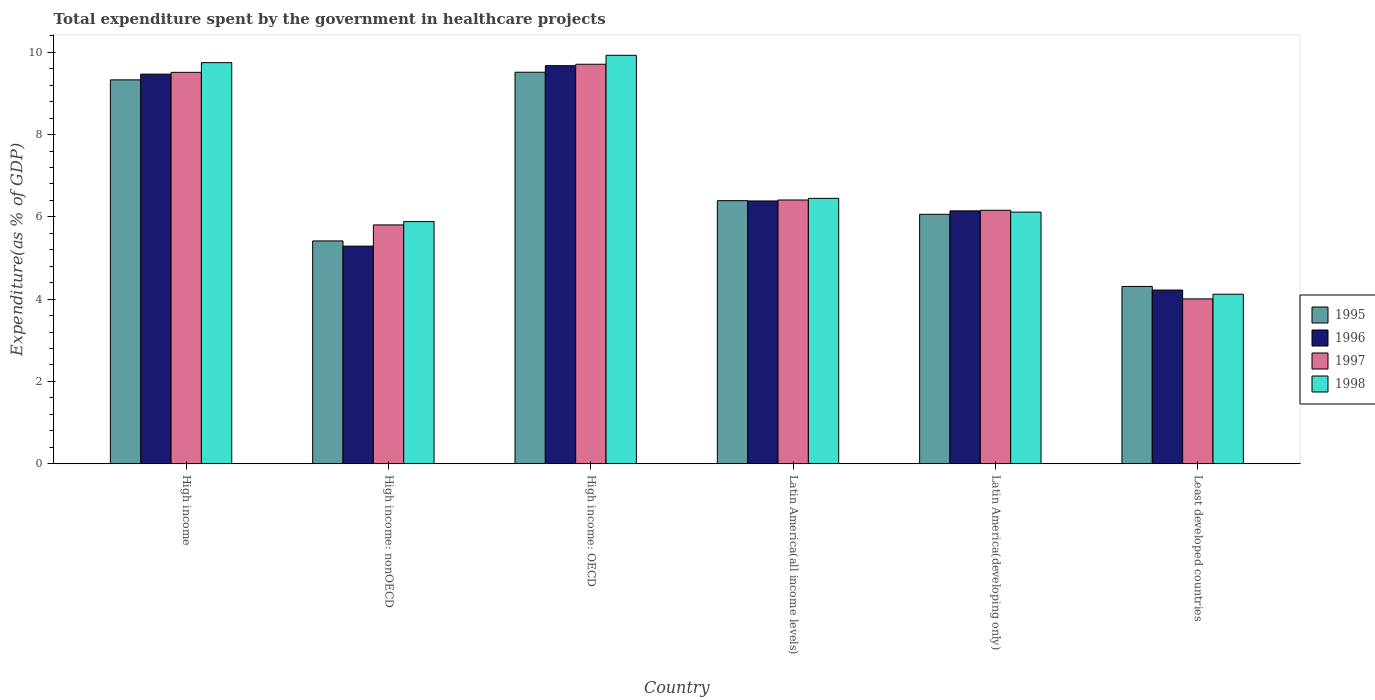Are the number of bars per tick equal to the number of legend labels?
Your answer should be very brief. Yes. Are the number of bars on each tick of the X-axis equal?
Offer a very short reply. Yes. What is the label of the 2nd group of bars from the left?
Make the answer very short. High income: nonOECD. What is the total expenditure spent by the government in healthcare projects in 1997 in High income: OECD?
Ensure brevity in your answer.  9.71. Across all countries, what is the maximum total expenditure spent by the government in healthcare projects in 1998?
Make the answer very short. 9.93. Across all countries, what is the minimum total expenditure spent by the government in healthcare projects in 1998?
Keep it short and to the point. 4.12. In which country was the total expenditure spent by the government in healthcare projects in 1996 maximum?
Keep it short and to the point. High income: OECD. In which country was the total expenditure spent by the government in healthcare projects in 1998 minimum?
Offer a very short reply. Least developed countries. What is the total total expenditure spent by the government in healthcare projects in 1996 in the graph?
Offer a very short reply. 41.18. What is the difference between the total expenditure spent by the government in healthcare projects in 1997 in Latin America(all income levels) and that in Latin America(developing only)?
Ensure brevity in your answer.  0.25. What is the difference between the total expenditure spent by the government in healthcare projects in 1996 in High income: nonOECD and the total expenditure spent by the government in healthcare projects in 1998 in Least developed countries?
Your answer should be very brief. 1.17. What is the average total expenditure spent by the government in healthcare projects in 1998 per country?
Offer a terse response. 7.04. What is the difference between the total expenditure spent by the government in healthcare projects of/in 1995 and total expenditure spent by the government in healthcare projects of/in 1996 in High income?
Offer a terse response. -0.14. In how many countries, is the total expenditure spent by the government in healthcare projects in 1998 greater than 8 %?
Ensure brevity in your answer.  2. What is the ratio of the total expenditure spent by the government in healthcare projects in 1998 in Latin America(developing only) to that in Least developed countries?
Your answer should be very brief. 1.48. Is the total expenditure spent by the government in healthcare projects in 1995 in High income: OECD less than that in Latin America(developing only)?
Give a very brief answer. No. What is the difference between the highest and the second highest total expenditure spent by the government in healthcare projects in 1996?
Ensure brevity in your answer.  0.2. What is the difference between the highest and the lowest total expenditure spent by the government in healthcare projects in 1997?
Your answer should be compact. 5.7. In how many countries, is the total expenditure spent by the government in healthcare projects in 1995 greater than the average total expenditure spent by the government in healthcare projects in 1995 taken over all countries?
Your answer should be compact. 2. Is it the case that in every country, the sum of the total expenditure spent by the government in healthcare projects in 1996 and total expenditure spent by the government in healthcare projects in 1997 is greater than the sum of total expenditure spent by the government in healthcare projects in 1998 and total expenditure spent by the government in healthcare projects in 1995?
Offer a terse response. No. What does the 3rd bar from the left in Latin America(all income levels) represents?
Your answer should be compact. 1997. How many countries are there in the graph?
Provide a succinct answer. 6. Where does the legend appear in the graph?
Offer a very short reply. Center right. How many legend labels are there?
Your answer should be very brief. 4. What is the title of the graph?
Give a very brief answer. Total expenditure spent by the government in healthcare projects. What is the label or title of the X-axis?
Keep it short and to the point. Country. What is the label or title of the Y-axis?
Provide a succinct answer. Expenditure(as % of GDP). What is the Expenditure(as % of GDP) of 1995 in High income?
Offer a terse response. 9.33. What is the Expenditure(as % of GDP) of 1996 in High income?
Offer a terse response. 9.47. What is the Expenditure(as % of GDP) in 1997 in High income?
Offer a very short reply. 9.51. What is the Expenditure(as % of GDP) of 1998 in High income?
Keep it short and to the point. 9.75. What is the Expenditure(as % of GDP) in 1995 in High income: nonOECD?
Your response must be concise. 5.41. What is the Expenditure(as % of GDP) of 1996 in High income: nonOECD?
Provide a succinct answer. 5.29. What is the Expenditure(as % of GDP) of 1997 in High income: nonOECD?
Your answer should be very brief. 5.8. What is the Expenditure(as % of GDP) of 1998 in High income: nonOECD?
Your answer should be very brief. 5.88. What is the Expenditure(as % of GDP) of 1995 in High income: OECD?
Ensure brevity in your answer.  9.51. What is the Expenditure(as % of GDP) of 1996 in High income: OECD?
Ensure brevity in your answer.  9.67. What is the Expenditure(as % of GDP) of 1997 in High income: OECD?
Your answer should be very brief. 9.71. What is the Expenditure(as % of GDP) of 1998 in High income: OECD?
Keep it short and to the point. 9.93. What is the Expenditure(as % of GDP) of 1995 in Latin America(all income levels)?
Give a very brief answer. 6.39. What is the Expenditure(as % of GDP) of 1996 in Latin America(all income levels)?
Provide a short and direct response. 6.39. What is the Expenditure(as % of GDP) in 1997 in Latin America(all income levels)?
Provide a succinct answer. 6.41. What is the Expenditure(as % of GDP) of 1998 in Latin America(all income levels)?
Your answer should be very brief. 6.45. What is the Expenditure(as % of GDP) in 1995 in Latin America(developing only)?
Your answer should be compact. 6.06. What is the Expenditure(as % of GDP) of 1996 in Latin America(developing only)?
Ensure brevity in your answer.  6.15. What is the Expenditure(as % of GDP) of 1997 in Latin America(developing only)?
Offer a very short reply. 6.16. What is the Expenditure(as % of GDP) of 1998 in Latin America(developing only)?
Ensure brevity in your answer.  6.12. What is the Expenditure(as % of GDP) in 1995 in Least developed countries?
Offer a terse response. 4.31. What is the Expenditure(as % of GDP) in 1996 in Least developed countries?
Ensure brevity in your answer.  4.22. What is the Expenditure(as % of GDP) in 1997 in Least developed countries?
Your answer should be very brief. 4.01. What is the Expenditure(as % of GDP) in 1998 in Least developed countries?
Keep it short and to the point. 4.12. Across all countries, what is the maximum Expenditure(as % of GDP) in 1995?
Ensure brevity in your answer.  9.51. Across all countries, what is the maximum Expenditure(as % of GDP) of 1996?
Give a very brief answer. 9.67. Across all countries, what is the maximum Expenditure(as % of GDP) of 1997?
Ensure brevity in your answer.  9.71. Across all countries, what is the maximum Expenditure(as % of GDP) of 1998?
Keep it short and to the point. 9.93. Across all countries, what is the minimum Expenditure(as % of GDP) of 1995?
Keep it short and to the point. 4.31. Across all countries, what is the minimum Expenditure(as % of GDP) in 1996?
Give a very brief answer. 4.22. Across all countries, what is the minimum Expenditure(as % of GDP) of 1997?
Provide a short and direct response. 4.01. Across all countries, what is the minimum Expenditure(as % of GDP) in 1998?
Ensure brevity in your answer.  4.12. What is the total Expenditure(as % of GDP) in 1995 in the graph?
Offer a terse response. 41.02. What is the total Expenditure(as % of GDP) of 1996 in the graph?
Offer a very short reply. 41.18. What is the total Expenditure(as % of GDP) of 1997 in the graph?
Your response must be concise. 41.6. What is the total Expenditure(as % of GDP) of 1998 in the graph?
Your answer should be very brief. 42.24. What is the difference between the Expenditure(as % of GDP) of 1995 in High income and that in High income: nonOECD?
Ensure brevity in your answer.  3.91. What is the difference between the Expenditure(as % of GDP) of 1996 in High income and that in High income: nonOECD?
Your response must be concise. 4.18. What is the difference between the Expenditure(as % of GDP) of 1997 in High income and that in High income: nonOECD?
Provide a succinct answer. 3.71. What is the difference between the Expenditure(as % of GDP) of 1998 in High income and that in High income: nonOECD?
Your response must be concise. 3.86. What is the difference between the Expenditure(as % of GDP) of 1995 in High income and that in High income: OECD?
Provide a succinct answer. -0.19. What is the difference between the Expenditure(as % of GDP) in 1996 in High income and that in High income: OECD?
Your answer should be very brief. -0.2. What is the difference between the Expenditure(as % of GDP) in 1997 in High income and that in High income: OECD?
Provide a short and direct response. -0.2. What is the difference between the Expenditure(as % of GDP) in 1998 in High income and that in High income: OECD?
Make the answer very short. -0.18. What is the difference between the Expenditure(as % of GDP) of 1995 in High income and that in Latin America(all income levels)?
Give a very brief answer. 2.94. What is the difference between the Expenditure(as % of GDP) in 1996 in High income and that in Latin America(all income levels)?
Provide a succinct answer. 3.08. What is the difference between the Expenditure(as % of GDP) of 1997 in High income and that in Latin America(all income levels)?
Your answer should be compact. 3.1. What is the difference between the Expenditure(as % of GDP) of 1998 in High income and that in Latin America(all income levels)?
Your answer should be compact. 3.3. What is the difference between the Expenditure(as % of GDP) in 1995 in High income and that in Latin America(developing only)?
Keep it short and to the point. 3.27. What is the difference between the Expenditure(as % of GDP) in 1996 in High income and that in Latin America(developing only)?
Your response must be concise. 3.32. What is the difference between the Expenditure(as % of GDP) of 1997 in High income and that in Latin America(developing only)?
Give a very brief answer. 3.35. What is the difference between the Expenditure(as % of GDP) in 1998 in High income and that in Latin America(developing only)?
Keep it short and to the point. 3.63. What is the difference between the Expenditure(as % of GDP) of 1995 in High income and that in Least developed countries?
Your answer should be very brief. 5.02. What is the difference between the Expenditure(as % of GDP) in 1996 in High income and that in Least developed countries?
Your response must be concise. 5.25. What is the difference between the Expenditure(as % of GDP) in 1997 in High income and that in Least developed countries?
Give a very brief answer. 5.51. What is the difference between the Expenditure(as % of GDP) of 1998 in High income and that in Least developed countries?
Give a very brief answer. 5.63. What is the difference between the Expenditure(as % of GDP) in 1995 in High income: nonOECD and that in High income: OECD?
Your answer should be very brief. -4.1. What is the difference between the Expenditure(as % of GDP) in 1996 in High income: nonOECD and that in High income: OECD?
Ensure brevity in your answer.  -4.38. What is the difference between the Expenditure(as % of GDP) in 1997 in High income: nonOECD and that in High income: OECD?
Provide a short and direct response. -3.9. What is the difference between the Expenditure(as % of GDP) in 1998 in High income: nonOECD and that in High income: OECD?
Provide a short and direct response. -4.04. What is the difference between the Expenditure(as % of GDP) in 1995 in High income: nonOECD and that in Latin America(all income levels)?
Offer a terse response. -0.98. What is the difference between the Expenditure(as % of GDP) in 1996 in High income: nonOECD and that in Latin America(all income levels)?
Your answer should be compact. -1.1. What is the difference between the Expenditure(as % of GDP) in 1997 in High income: nonOECD and that in Latin America(all income levels)?
Ensure brevity in your answer.  -0.61. What is the difference between the Expenditure(as % of GDP) in 1998 in High income: nonOECD and that in Latin America(all income levels)?
Your response must be concise. -0.56. What is the difference between the Expenditure(as % of GDP) of 1995 in High income: nonOECD and that in Latin America(developing only)?
Provide a short and direct response. -0.65. What is the difference between the Expenditure(as % of GDP) of 1996 in High income: nonOECD and that in Latin America(developing only)?
Keep it short and to the point. -0.86. What is the difference between the Expenditure(as % of GDP) of 1997 in High income: nonOECD and that in Latin America(developing only)?
Ensure brevity in your answer.  -0.36. What is the difference between the Expenditure(as % of GDP) in 1998 in High income: nonOECD and that in Latin America(developing only)?
Your answer should be very brief. -0.23. What is the difference between the Expenditure(as % of GDP) of 1995 in High income: nonOECD and that in Least developed countries?
Ensure brevity in your answer.  1.11. What is the difference between the Expenditure(as % of GDP) in 1996 in High income: nonOECD and that in Least developed countries?
Your response must be concise. 1.07. What is the difference between the Expenditure(as % of GDP) of 1997 in High income: nonOECD and that in Least developed countries?
Offer a terse response. 1.8. What is the difference between the Expenditure(as % of GDP) in 1998 in High income: nonOECD and that in Least developed countries?
Ensure brevity in your answer.  1.76. What is the difference between the Expenditure(as % of GDP) in 1995 in High income: OECD and that in Latin America(all income levels)?
Provide a succinct answer. 3.12. What is the difference between the Expenditure(as % of GDP) in 1996 in High income: OECD and that in Latin America(all income levels)?
Make the answer very short. 3.29. What is the difference between the Expenditure(as % of GDP) of 1997 in High income: OECD and that in Latin America(all income levels)?
Offer a very short reply. 3.3. What is the difference between the Expenditure(as % of GDP) of 1998 in High income: OECD and that in Latin America(all income levels)?
Your response must be concise. 3.48. What is the difference between the Expenditure(as % of GDP) in 1995 in High income: OECD and that in Latin America(developing only)?
Provide a succinct answer. 3.45. What is the difference between the Expenditure(as % of GDP) in 1996 in High income: OECD and that in Latin America(developing only)?
Offer a terse response. 3.53. What is the difference between the Expenditure(as % of GDP) in 1997 in High income: OECD and that in Latin America(developing only)?
Your answer should be very brief. 3.55. What is the difference between the Expenditure(as % of GDP) in 1998 in High income: OECD and that in Latin America(developing only)?
Your answer should be compact. 3.81. What is the difference between the Expenditure(as % of GDP) of 1995 in High income: OECD and that in Least developed countries?
Your answer should be very brief. 5.21. What is the difference between the Expenditure(as % of GDP) in 1996 in High income: OECD and that in Least developed countries?
Make the answer very short. 5.45. What is the difference between the Expenditure(as % of GDP) of 1997 in High income: OECD and that in Least developed countries?
Your response must be concise. 5.7. What is the difference between the Expenditure(as % of GDP) of 1998 in High income: OECD and that in Least developed countries?
Your response must be concise. 5.81. What is the difference between the Expenditure(as % of GDP) of 1995 in Latin America(all income levels) and that in Latin America(developing only)?
Ensure brevity in your answer.  0.33. What is the difference between the Expenditure(as % of GDP) in 1996 in Latin America(all income levels) and that in Latin America(developing only)?
Your response must be concise. 0.24. What is the difference between the Expenditure(as % of GDP) of 1997 in Latin America(all income levels) and that in Latin America(developing only)?
Keep it short and to the point. 0.25. What is the difference between the Expenditure(as % of GDP) of 1998 in Latin America(all income levels) and that in Latin America(developing only)?
Provide a short and direct response. 0.33. What is the difference between the Expenditure(as % of GDP) in 1995 in Latin America(all income levels) and that in Least developed countries?
Give a very brief answer. 2.08. What is the difference between the Expenditure(as % of GDP) in 1996 in Latin America(all income levels) and that in Least developed countries?
Provide a succinct answer. 2.16. What is the difference between the Expenditure(as % of GDP) of 1997 in Latin America(all income levels) and that in Least developed countries?
Your answer should be compact. 2.4. What is the difference between the Expenditure(as % of GDP) of 1998 in Latin America(all income levels) and that in Least developed countries?
Keep it short and to the point. 2.33. What is the difference between the Expenditure(as % of GDP) of 1995 in Latin America(developing only) and that in Least developed countries?
Offer a terse response. 1.75. What is the difference between the Expenditure(as % of GDP) in 1996 in Latin America(developing only) and that in Least developed countries?
Give a very brief answer. 1.92. What is the difference between the Expenditure(as % of GDP) in 1997 in Latin America(developing only) and that in Least developed countries?
Offer a terse response. 2.15. What is the difference between the Expenditure(as % of GDP) of 1998 in Latin America(developing only) and that in Least developed countries?
Offer a very short reply. 2. What is the difference between the Expenditure(as % of GDP) of 1995 in High income and the Expenditure(as % of GDP) of 1996 in High income: nonOECD?
Provide a short and direct response. 4.04. What is the difference between the Expenditure(as % of GDP) in 1995 in High income and the Expenditure(as % of GDP) in 1997 in High income: nonOECD?
Make the answer very short. 3.53. What is the difference between the Expenditure(as % of GDP) of 1995 in High income and the Expenditure(as % of GDP) of 1998 in High income: nonOECD?
Provide a short and direct response. 3.44. What is the difference between the Expenditure(as % of GDP) in 1996 in High income and the Expenditure(as % of GDP) in 1997 in High income: nonOECD?
Offer a very short reply. 3.66. What is the difference between the Expenditure(as % of GDP) of 1996 in High income and the Expenditure(as % of GDP) of 1998 in High income: nonOECD?
Your answer should be compact. 3.58. What is the difference between the Expenditure(as % of GDP) in 1997 in High income and the Expenditure(as % of GDP) in 1998 in High income: nonOECD?
Your answer should be very brief. 3.63. What is the difference between the Expenditure(as % of GDP) in 1995 in High income and the Expenditure(as % of GDP) in 1996 in High income: OECD?
Offer a very short reply. -0.34. What is the difference between the Expenditure(as % of GDP) of 1995 in High income and the Expenditure(as % of GDP) of 1997 in High income: OECD?
Provide a succinct answer. -0.38. What is the difference between the Expenditure(as % of GDP) in 1995 in High income and the Expenditure(as % of GDP) in 1998 in High income: OECD?
Ensure brevity in your answer.  -0.6. What is the difference between the Expenditure(as % of GDP) of 1996 in High income and the Expenditure(as % of GDP) of 1997 in High income: OECD?
Provide a succinct answer. -0.24. What is the difference between the Expenditure(as % of GDP) of 1996 in High income and the Expenditure(as % of GDP) of 1998 in High income: OECD?
Provide a short and direct response. -0.46. What is the difference between the Expenditure(as % of GDP) in 1997 in High income and the Expenditure(as % of GDP) in 1998 in High income: OECD?
Make the answer very short. -0.41. What is the difference between the Expenditure(as % of GDP) in 1995 in High income and the Expenditure(as % of GDP) in 1996 in Latin America(all income levels)?
Keep it short and to the point. 2.94. What is the difference between the Expenditure(as % of GDP) of 1995 in High income and the Expenditure(as % of GDP) of 1997 in Latin America(all income levels)?
Offer a terse response. 2.92. What is the difference between the Expenditure(as % of GDP) in 1995 in High income and the Expenditure(as % of GDP) in 1998 in Latin America(all income levels)?
Offer a terse response. 2.88. What is the difference between the Expenditure(as % of GDP) of 1996 in High income and the Expenditure(as % of GDP) of 1997 in Latin America(all income levels)?
Ensure brevity in your answer.  3.06. What is the difference between the Expenditure(as % of GDP) in 1996 in High income and the Expenditure(as % of GDP) in 1998 in Latin America(all income levels)?
Ensure brevity in your answer.  3.02. What is the difference between the Expenditure(as % of GDP) of 1997 in High income and the Expenditure(as % of GDP) of 1998 in Latin America(all income levels)?
Offer a terse response. 3.06. What is the difference between the Expenditure(as % of GDP) in 1995 in High income and the Expenditure(as % of GDP) in 1996 in Latin America(developing only)?
Ensure brevity in your answer.  3.18. What is the difference between the Expenditure(as % of GDP) in 1995 in High income and the Expenditure(as % of GDP) in 1997 in Latin America(developing only)?
Your answer should be very brief. 3.17. What is the difference between the Expenditure(as % of GDP) of 1995 in High income and the Expenditure(as % of GDP) of 1998 in Latin America(developing only)?
Provide a short and direct response. 3.21. What is the difference between the Expenditure(as % of GDP) in 1996 in High income and the Expenditure(as % of GDP) in 1997 in Latin America(developing only)?
Your answer should be very brief. 3.31. What is the difference between the Expenditure(as % of GDP) of 1996 in High income and the Expenditure(as % of GDP) of 1998 in Latin America(developing only)?
Make the answer very short. 3.35. What is the difference between the Expenditure(as % of GDP) in 1997 in High income and the Expenditure(as % of GDP) in 1998 in Latin America(developing only)?
Give a very brief answer. 3.4. What is the difference between the Expenditure(as % of GDP) of 1995 in High income and the Expenditure(as % of GDP) of 1996 in Least developed countries?
Your response must be concise. 5.11. What is the difference between the Expenditure(as % of GDP) in 1995 in High income and the Expenditure(as % of GDP) in 1997 in Least developed countries?
Give a very brief answer. 5.32. What is the difference between the Expenditure(as % of GDP) of 1995 in High income and the Expenditure(as % of GDP) of 1998 in Least developed countries?
Provide a short and direct response. 5.21. What is the difference between the Expenditure(as % of GDP) of 1996 in High income and the Expenditure(as % of GDP) of 1997 in Least developed countries?
Provide a short and direct response. 5.46. What is the difference between the Expenditure(as % of GDP) in 1996 in High income and the Expenditure(as % of GDP) in 1998 in Least developed countries?
Offer a terse response. 5.35. What is the difference between the Expenditure(as % of GDP) in 1997 in High income and the Expenditure(as % of GDP) in 1998 in Least developed countries?
Offer a terse response. 5.39. What is the difference between the Expenditure(as % of GDP) in 1995 in High income: nonOECD and the Expenditure(as % of GDP) in 1996 in High income: OECD?
Keep it short and to the point. -4.26. What is the difference between the Expenditure(as % of GDP) in 1995 in High income: nonOECD and the Expenditure(as % of GDP) in 1997 in High income: OECD?
Provide a succinct answer. -4.29. What is the difference between the Expenditure(as % of GDP) of 1995 in High income: nonOECD and the Expenditure(as % of GDP) of 1998 in High income: OECD?
Provide a short and direct response. -4.51. What is the difference between the Expenditure(as % of GDP) of 1996 in High income: nonOECD and the Expenditure(as % of GDP) of 1997 in High income: OECD?
Your answer should be very brief. -4.42. What is the difference between the Expenditure(as % of GDP) in 1996 in High income: nonOECD and the Expenditure(as % of GDP) in 1998 in High income: OECD?
Give a very brief answer. -4.64. What is the difference between the Expenditure(as % of GDP) of 1997 in High income: nonOECD and the Expenditure(as % of GDP) of 1998 in High income: OECD?
Give a very brief answer. -4.12. What is the difference between the Expenditure(as % of GDP) of 1995 in High income: nonOECD and the Expenditure(as % of GDP) of 1996 in Latin America(all income levels)?
Give a very brief answer. -0.97. What is the difference between the Expenditure(as % of GDP) in 1995 in High income: nonOECD and the Expenditure(as % of GDP) in 1997 in Latin America(all income levels)?
Give a very brief answer. -0.99. What is the difference between the Expenditure(as % of GDP) of 1995 in High income: nonOECD and the Expenditure(as % of GDP) of 1998 in Latin America(all income levels)?
Provide a short and direct response. -1.03. What is the difference between the Expenditure(as % of GDP) in 1996 in High income: nonOECD and the Expenditure(as % of GDP) in 1997 in Latin America(all income levels)?
Give a very brief answer. -1.12. What is the difference between the Expenditure(as % of GDP) of 1996 in High income: nonOECD and the Expenditure(as % of GDP) of 1998 in Latin America(all income levels)?
Provide a short and direct response. -1.16. What is the difference between the Expenditure(as % of GDP) in 1997 in High income: nonOECD and the Expenditure(as % of GDP) in 1998 in Latin America(all income levels)?
Provide a succinct answer. -0.65. What is the difference between the Expenditure(as % of GDP) in 1995 in High income: nonOECD and the Expenditure(as % of GDP) in 1996 in Latin America(developing only)?
Make the answer very short. -0.73. What is the difference between the Expenditure(as % of GDP) in 1995 in High income: nonOECD and the Expenditure(as % of GDP) in 1997 in Latin America(developing only)?
Provide a succinct answer. -0.74. What is the difference between the Expenditure(as % of GDP) of 1995 in High income: nonOECD and the Expenditure(as % of GDP) of 1998 in Latin America(developing only)?
Keep it short and to the point. -0.7. What is the difference between the Expenditure(as % of GDP) of 1996 in High income: nonOECD and the Expenditure(as % of GDP) of 1997 in Latin America(developing only)?
Ensure brevity in your answer.  -0.87. What is the difference between the Expenditure(as % of GDP) in 1996 in High income: nonOECD and the Expenditure(as % of GDP) in 1998 in Latin America(developing only)?
Give a very brief answer. -0.83. What is the difference between the Expenditure(as % of GDP) of 1997 in High income: nonOECD and the Expenditure(as % of GDP) of 1998 in Latin America(developing only)?
Offer a very short reply. -0.31. What is the difference between the Expenditure(as % of GDP) of 1995 in High income: nonOECD and the Expenditure(as % of GDP) of 1996 in Least developed countries?
Your answer should be compact. 1.19. What is the difference between the Expenditure(as % of GDP) in 1995 in High income: nonOECD and the Expenditure(as % of GDP) in 1997 in Least developed countries?
Your answer should be very brief. 1.41. What is the difference between the Expenditure(as % of GDP) of 1995 in High income: nonOECD and the Expenditure(as % of GDP) of 1998 in Least developed countries?
Offer a very short reply. 1.29. What is the difference between the Expenditure(as % of GDP) in 1996 in High income: nonOECD and the Expenditure(as % of GDP) in 1997 in Least developed countries?
Ensure brevity in your answer.  1.28. What is the difference between the Expenditure(as % of GDP) of 1996 in High income: nonOECD and the Expenditure(as % of GDP) of 1998 in Least developed countries?
Provide a short and direct response. 1.17. What is the difference between the Expenditure(as % of GDP) in 1997 in High income: nonOECD and the Expenditure(as % of GDP) in 1998 in Least developed countries?
Offer a terse response. 1.68. What is the difference between the Expenditure(as % of GDP) in 1995 in High income: OECD and the Expenditure(as % of GDP) in 1996 in Latin America(all income levels)?
Make the answer very short. 3.13. What is the difference between the Expenditure(as % of GDP) in 1995 in High income: OECD and the Expenditure(as % of GDP) in 1997 in Latin America(all income levels)?
Provide a short and direct response. 3.1. What is the difference between the Expenditure(as % of GDP) of 1995 in High income: OECD and the Expenditure(as % of GDP) of 1998 in Latin America(all income levels)?
Your response must be concise. 3.06. What is the difference between the Expenditure(as % of GDP) in 1996 in High income: OECD and the Expenditure(as % of GDP) in 1997 in Latin America(all income levels)?
Give a very brief answer. 3.26. What is the difference between the Expenditure(as % of GDP) of 1996 in High income: OECD and the Expenditure(as % of GDP) of 1998 in Latin America(all income levels)?
Ensure brevity in your answer.  3.22. What is the difference between the Expenditure(as % of GDP) in 1997 in High income: OECD and the Expenditure(as % of GDP) in 1998 in Latin America(all income levels)?
Your answer should be compact. 3.26. What is the difference between the Expenditure(as % of GDP) in 1995 in High income: OECD and the Expenditure(as % of GDP) in 1996 in Latin America(developing only)?
Offer a terse response. 3.37. What is the difference between the Expenditure(as % of GDP) of 1995 in High income: OECD and the Expenditure(as % of GDP) of 1997 in Latin America(developing only)?
Your response must be concise. 3.35. What is the difference between the Expenditure(as % of GDP) of 1995 in High income: OECD and the Expenditure(as % of GDP) of 1998 in Latin America(developing only)?
Make the answer very short. 3.4. What is the difference between the Expenditure(as % of GDP) in 1996 in High income: OECD and the Expenditure(as % of GDP) in 1997 in Latin America(developing only)?
Offer a very short reply. 3.51. What is the difference between the Expenditure(as % of GDP) in 1996 in High income: OECD and the Expenditure(as % of GDP) in 1998 in Latin America(developing only)?
Provide a succinct answer. 3.56. What is the difference between the Expenditure(as % of GDP) of 1997 in High income: OECD and the Expenditure(as % of GDP) of 1998 in Latin America(developing only)?
Provide a short and direct response. 3.59. What is the difference between the Expenditure(as % of GDP) of 1995 in High income: OECD and the Expenditure(as % of GDP) of 1996 in Least developed countries?
Keep it short and to the point. 5.29. What is the difference between the Expenditure(as % of GDP) in 1995 in High income: OECD and the Expenditure(as % of GDP) in 1997 in Least developed countries?
Your answer should be compact. 5.51. What is the difference between the Expenditure(as % of GDP) of 1995 in High income: OECD and the Expenditure(as % of GDP) of 1998 in Least developed countries?
Make the answer very short. 5.39. What is the difference between the Expenditure(as % of GDP) in 1996 in High income: OECD and the Expenditure(as % of GDP) in 1997 in Least developed countries?
Offer a very short reply. 5.67. What is the difference between the Expenditure(as % of GDP) in 1996 in High income: OECD and the Expenditure(as % of GDP) in 1998 in Least developed countries?
Provide a succinct answer. 5.55. What is the difference between the Expenditure(as % of GDP) of 1997 in High income: OECD and the Expenditure(as % of GDP) of 1998 in Least developed countries?
Your response must be concise. 5.59. What is the difference between the Expenditure(as % of GDP) of 1995 in Latin America(all income levels) and the Expenditure(as % of GDP) of 1996 in Latin America(developing only)?
Ensure brevity in your answer.  0.25. What is the difference between the Expenditure(as % of GDP) in 1995 in Latin America(all income levels) and the Expenditure(as % of GDP) in 1997 in Latin America(developing only)?
Offer a very short reply. 0.23. What is the difference between the Expenditure(as % of GDP) in 1995 in Latin America(all income levels) and the Expenditure(as % of GDP) in 1998 in Latin America(developing only)?
Your answer should be compact. 0.28. What is the difference between the Expenditure(as % of GDP) of 1996 in Latin America(all income levels) and the Expenditure(as % of GDP) of 1997 in Latin America(developing only)?
Give a very brief answer. 0.23. What is the difference between the Expenditure(as % of GDP) of 1996 in Latin America(all income levels) and the Expenditure(as % of GDP) of 1998 in Latin America(developing only)?
Your answer should be very brief. 0.27. What is the difference between the Expenditure(as % of GDP) in 1997 in Latin America(all income levels) and the Expenditure(as % of GDP) in 1998 in Latin America(developing only)?
Your answer should be compact. 0.29. What is the difference between the Expenditure(as % of GDP) of 1995 in Latin America(all income levels) and the Expenditure(as % of GDP) of 1996 in Least developed countries?
Keep it short and to the point. 2.17. What is the difference between the Expenditure(as % of GDP) of 1995 in Latin America(all income levels) and the Expenditure(as % of GDP) of 1997 in Least developed countries?
Your answer should be compact. 2.39. What is the difference between the Expenditure(as % of GDP) in 1995 in Latin America(all income levels) and the Expenditure(as % of GDP) in 1998 in Least developed countries?
Make the answer very short. 2.27. What is the difference between the Expenditure(as % of GDP) in 1996 in Latin America(all income levels) and the Expenditure(as % of GDP) in 1997 in Least developed countries?
Give a very brief answer. 2.38. What is the difference between the Expenditure(as % of GDP) of 1996 in Latin America(all income levels) and the Expenditure(as % of GDP) of 1998 in Least developed countries?
Provide a short and direct response. 2.27. What is the difference between the Expenditure(as % of GDP) in 1997 in Latin America(all income levels) and the Expenditure(as % of GDP) in 1998 in Least developed countries?
Your answer should be compact. 2.29. What is the difference between the Expenditure(as % of GDP) in 1995 in Latin America(developing only) and the Expenditure(as % of GDP) in 1996 in Least developed countries?
Ensure brevity in your answer.  1.84. What is the difference between the Expenditure(as % of GDP) of 1995 in Latin America(developing only) and the Expenditure(as % of GDP) of 1997 in Least developed countries?
Your response must be concise. 2.06. What is the difference between the Expenditure(as % of GDP) in 1995 in Latin America(developing only) and the Expenditure(as % of GDP) in 1998 in Least developed countries?
Keep it short and to the point. 1.94. What is the difference between the Expenditure(as % of GDP) in 1996 in Latin America(developing only) and the Expenditure(as % of GDP) in 1997 in Least developed countries?
Your answer should be compact. 2.14. What is the difference between the Expenditure(as % of GDP) in 1996 in Latin America(developing only) and the Expenditure(as % of GDP) in 1998 in Least developed countries?
Give a very brief answer. 2.03. What is the difference between the Expenditure(as % of GDP) in 1997 in Latin America(developing only) and the Expenditure(as % of GDP) in 1998 in Least developed countries?
Provide a succinct answer. 2.04. What is the average Expenditure(as % of GDP) in 1995 per country?
Your response must be concise. 6.84. What is the average Expenditure(as % of GDP) in 1996 per country?
Provide a short and direct response. 6.86. What is the average Expenditure(as % of GDP) in 1997 per country?
Ensure brevity in your answer.  6.93. What is the average Expenditure(as % of GDP) in 1998 per country?
Make the answer very short. 7.04. What is the difference between the Expenditure(as % of GDP) in 1995 and Expenditure(as % of GDP) in 1996 in High income?
Your answer should be compact. -0.14. What is the difference between the Expenditure(as % of GDP) of 1995 and Expenditure(as % of GDP) of 1997 in High income?
Your response must be concise. -0.18. What is the difference between the Expenditure(as % of GDP) of 1995 and Expenditure(as % of GDP) of 1998 in High income?
Your response must be concise. -0.42. What is the difference between the Expenditure(as % of GDP) of 1996 and Expenditure(as % of GDP) of 1997 in High income?
Your response must be concise. -0.04. What is the difference between the Expenditure(as % of GDP) of 1996 and Expenditure(as % of GDP) of 1998 in High income?
Keep it short and to the point. -0.28. What is the difference between the Expenditure(as % of GDP) of 1997 and Expenditure(as % of GDP) of 1998 in High income?
Keep it short and to the point. -0.24. What is the difference between the Expenditure(as % of GDP) of 1995 and Expenditure(as % of GDP) of 1996 in High income: nonOECD?
Your answer should be compact. 0.13. What is the difference between the Expenditure(as % of GDP) of 1995 and Expenditure(as % of GDP) of 1997 in High income: nonOECD?
Keep it short and to the point. -0.39. What is the difference between the Expenditure(as % of GDP) in 1995 and Expenditure(as % of GDP) in 1998 in High income: nonOECD?
Provide a short and direct response. -0.47. What is the difference between the Expenditure(as % of GDP) in 1996 and Expenditure(as % of GDP) in 1997 in High income: nonOECD?
Keep it short and to the point. -0.52. What is the difference between the Expenditure(as % of GDP) of 1996 and Expenditure(as % of GDP) of 1998 in High income: nonOECD?
Provide a short and direct response. -0.6. What is the difference between the Expenditure(as % of GDP) in 1997 and Expenditure(as % of GDP) in 1998 in High income: nonOECD?
Give a very brief answer. -0.08. What is the difference between the Expenditure(as % of GDP) in 1995 and Expenditure(as % of GDP) in 1996 in High income: OECD?
Provide a succinct answer. -0.16. What is the difference between the Expenditure(as % of GDP) of 1995 and Expenditure(as % of GDP) of 1997 in High income: OECD?
Provide a short and direct response. -0.19. What is the difference between the Expenditure(as % of GDP) of 1995 and Expenditure(as % of GDP) of 1998 in High income: OECD?
Give a very brief answer. -0.41. What is the difference between the Expenditure(as % of GDP) of 1996 and Expenditure(as % of GDP) of 1997 in High income: OECD?
Provide a succinct answer. -0.03. What is the difference between the Expenditure(as % of GDP) in 1996 and Expenditure(as % of GDP) in 1998 in High income: OECD?
Provide a short and direct response. -0.25. What is the difference between the Expenditure(as % of GDP) in 1997 and Expenditure(as % of GDP) in 1998 in High income: OECD?
Provide a succinct answer. -0.22. What is the difference between the Expenditure(as % of GDP) of 1995 and Expenditure(as % of GDP) of 1996 in Latin America(all income levels)?
Your answer should be compact. 0.01. What is the difference between the Expenditure(as % of GDP) in 1995 and Expenditure(as % of GDP) in 1997 in Latin America(all income levels)?
Keep it short and to the point. -0.02. What is the difference between the Expenditure(as % of GDP) of 1995 and Expenditure(as % of GDP) of 1998 in Latin America(all income levels)?
Offer a very short reply. -0.06. What is the difference between the Expenditure(as % of GDP) of 1996 and Expenditure(as % of GDP) of 1997 in Latin America(all income levels)?
Give a very brief answer. -0.02. What is the difference between the Expenditure(as % of GDP) of 1996 and Expenditure(as % of GDP) of 1998 in Latin America(all income levels)?
Provide a short and direct response. -0.06. What is the difference between the Expenditure(as % of GDP) of 1997 and Expenditure(as % of GDP) of 1998 in Latin America(all income levels)?
Keep it short and to the point. -0.04. What is the difference between the Expenditure(as % of GDP) in 1995 and Expenditure(as % of GDP) in 1996 in Latin America(developing only)?
Provide a succinct answer. -0.08. What is the difference between the Expenditure(as % of GDP) of 1995 and Expenditure(as % of GDP) of 1997 in Latin America(developing only)?
Keep it short and to the point. -0.1. What is the difference between the Expenditure(as % of GDP) in 1995 and Expenditure(as % of GDP) in 1998 in Latin America(developing only)?
Provide a succinct answer. -0.05. What is the difference between the Expenditure(as % of GDP) in 1996 and Expenditure(as % of GDP) in 1997 in Latin America(developing only)?
Your answer should be very brief. -0.01. What is the difference between the Expenditure(as % of GDP) of 1997 and Expenditure(as % of GDP) of 1998 in Latin America(developing only)?
Provide a short and direct response. 0.04. What is the difference between the Expenditure(as % of GDP) in 1995 and Expenditure(as % of GDP) in 1996 in Least developed countries?
Provide a succinct answer. 0.09. What is the difference between the Expenditure(as % of GDP) of 1995 and Expenditure(as % of GDP) of 1997 in Least developed countries?
Offer a terse response. 0.3. What is the difference between the Expenditure(as % of GDP) of 1995 and Expenditure(as % of GDP) of 1998 in Least developed countries?
Your response must be concise. 0.19. What is the difference between the Expenditure(as % of GDP) of 1996 and Expenditure(as % of GDP) of 1997 in Least developed countries?
Provide a short and direct response. 0.21. What is the difference between the Expenditure(as % of GDP) of 1996 and Expenditure(as % of GDP) of 1998 in Least developed countries?
Your answer should be compact. 0.1. What is the difference between the Expenditure(as % of GDP) in 1997 and Expenditure(as % of GDP) in 1998 in Least developed countries?
Make the answer very short. -0.11. What is the ratio of the Expenditure(as % of GDP) in 1995 in High income to that in High income: nonOECD?
Keep it short and to the point. 1.72. What is the ratio of the Expenditure(as % of GDP) in 1996 in High income to that in High income: nonOECD?
Your response must be concise. 1.79. What is the ratio of the Expenditure(as % of GDP) of 1997 in High income to that in High income: nonOECD?
Your response must be concise. 1.64. What is the ratio of the Expenditure(as % of GDP) in 1998 in High income to that in High income: nonOECD?
Ensure brevity in your answer.  1.66. What is the ratio of the Expenditure(as % of GDP) in 1995 in High income to that in High income: OECD?
Provide a short and direct response. 0.98. What is the ratio of the Expenditure(as % of GDP) of 1996 in High income to that in High income: OECD?
Your answer should be very brief. 0.98. What is the ratio of the Expenditure(as % of GDP) of 1997 in High income to that in High income: OECD?
Keep it short and to the point. 0.98. What is the ratio of the Expenditure(as % of GDP) of 1998 in High income to that in High income: OECD?
Provide a succinct answer. 0.98. What is the ratio of the Expenditure(as % of GDP) of 1995 in High income to that in Latin America(all income levels)?
Your response must be concise. 1.46. What is the ratio of the Expenditure(as % of GDP) of 1996 in High income to that in Latin America(all income levels)?
Provide a short and direct response. 1.48. What is the ratio of the Expenditure(as % of GDP) in 1997 in High income to that in Latin America(all income levels)?
Your answer should be compact. 1.48. What is the ratio of the Expenditure(as % of GDP) of 1998 in High income to that in Latin America(all income levels)?
Your answer should be very brief. 1.51. What is the ratio of the Expenditure(as % of GDP) in 1995 in High income to that in Latin America(developing only)?
Offer a terse response. 1.54. What is the ratio of the Expenditure(as % of GDP) of 1996 in High income to that in Latin America(developing only)?
Keep it short and to the point. 1.54. What is the ratio of the Expenditure(as % of GDP) of 1997 in High income to that in Latin America(developing only)?
Provide a short and direct response. 1.54. What is the ratio of the Expenditure(as % of GDP) of 1998 in High income to that in Latin America(developing only)?
Provide a succinct answer. 1.59. What is the ratio of the Expenditure(as % of GDP) of 1995 in High income to that in Least developed countries?
Offer a terse response. 2.17. What is the ratio of the Expenditure(as % of GDP) in 1996 in High income to that in Least developed countries?
Your response must be concise. 2.24. What is the ratio of the Expenditure(as % of GDP) of 1997 in High income to that in Least developed countries?
Keep it short and to the point. 2.37. What is the ratio of the Expenditure(as % of GDP) of 1998 in High income to that in Least developed countries?
Offer a terse response. 2.37. What is the ratio of the Expenditure(as % of GDP) of 1995 in High income: nonOECD to that in High income: OECD?
Your answer should be very brief. 0.57. What is the ratio of the Expenditure(as % of GDP) in 1996 in High income: nonOECD to that in High income: OECD?
Ensure brevity in your answer.  0.55. What is the ratio of the Expenditure(as % of GDP) of 1997 in High income: nonOECD to that in High income: OECD?
Keep it short and to the point. 0.6. What is the ratio of the Expenditure(as % of GDP) of 1998 in High income: nonOECD to that in High income: OECD?
Keep it short and to the point. 0.59. What is the ratio of the Expenditure(as % of GDP) in 1995 in High income: nonOECD to that in Latin America(all income levels)?
Give a very brief answer. 0.85. What is the ratio of the Expenditure(as % of GDP) of 1996 in High income: nonOECD to that in Latin America(all income levels)?
Your response must be concise. 0.83. What is the ratio of the Expenditure(as % of GDP) of 1997 in High income: nonOECD to that in Latin America(all income levels)?
Keep it short and to the point. 0.91. What is the ratio of the Expenditure(as % of GDP) in 1998 in High income: nonOECD to that in Latin America(all income levels)?
Keep it short and to the point. 0.91. What is the ratio of the Expenditure(as % of GDP) in 1995 in High income: nonOECD to that in Latin America(developing only)?
Make the answer very short. 0.89. What is the ratio of the Expenditure(as % of GDP) of 1996 in High income: nonOECD to that in Latin America(developing only)?
Offer a very short reply. 0.86. What is the ratio of the Expenditure(as % of GDP) in 1997 in High income: nonOECD to that in Latin America(developing only)?
Provide a short and direct response. 0.94. What is the ratio of the Expenditure(as % of GDP) of 1998 in High income: nonOECD to that in Latin America(developing only)?
Offer a very short reply. 0.96. What is the ratio of the Expenditure(as % of GDP) in 1995 in High income: nonOECD to that in Least developed countries?
Give a very brief answer. 1.26. What is the ratio of the Expenditure(as % of GDP) of 1996 in High income: nonOECD to that in Least developed countries?
Ensure brevity in your answer.  1.25. What is the ratio of the Expenditure(as % of GDP) of 1997 in High income: nonOECD to that in Least developed countries?
Ensure brevity in your answer.  1.45. What is the ratio of the Expenditure(as % of GDP) in 1998 in High income: nonOECD to that in Least developed countries?
Your answer should be compact. 1.43. What is the ratio of the Expenditure(as % of GDP) in 1995 in High income: OECD to that in Latin America(all income levels)?
Keep it short and to the point. 1.49. What is the ratio of the Expenditure(as % of GDP) of 1996 in High income: OECD to that in Latin America(all income levels)?
Provide a short and direct response. 1.51. What is the ratio of the Expenditure(as % of GDP) in 1997 in High income: OECD to that in Latin America(all income levels)?
Offer a terse response. 1.51. What is the ratio of the Expenditure(as % of GDP) of 1998 in High income: OECD to that in Latin America(all income levels)?
Provide a short and direct response. 1.54. What is the ratio of the Expenditure(as % of GDP) of 1995 in High income: OECD to that in Latin America(developing only)?
Ensure brevity in your answer.  1.57. What is the ratio of the Expenditure(as % of GDP) of 1996 in High income: OECD to that in Latin America(developing only)?
Make the answer very short. 1.57. What is the ratio of the Expenditure(as % of GDP) in 1997 in High income: OECD to that in Latin America(developing only)?
Provide a succinct answer. 1.58. What is the ratio of the Expenditure(as % of GDP) in 1998 in High income: OECD to that in Latin America(developing only)?
Your answer should be very brief. 1.62. What is the ratio of the Expenditure(as % of GDP) of 1995 in High income: OECD to that in Least developed countries?
Your answer should be very brief. 2.21. What is the ratio of the Expenditure(as % of GDP) in 1996 in High income: OECD to that in Least developed countries?
Keep it short and to the point. 2.29. What is the ratio of the Expenditure(as % of GDP) in 1997 in High income: OECD to that in Least developed countries?
Provide a succinct answer. 2.42. What is the ratio of the Expenditure(as % of GDP) in 1998 in High income: OECD to that in Least developed countries?
Your response must be concise. 2.41. What is the ratio of the Expenditure(as % of GDP) of 1995 in Latin America(all income levels) to that in Latin America(developing only)?
Keep it short and to the point. 1.05. What is the ratio of the Expenditure(as % of GDP) of 1996 in Latin America(all income levels) to that in Latin America(developing only)?
Make the answer very short. 1.04. What is the ratio of the Expenditure(as % of GDP) of 1997 in Latin America(all income levels) to that in Latin America(developing only)?
Ensure brevity in your answer.  1.04. What is the ratio of the Expenditure(as % of GDP) in 1998 in Latin America(all income levels) to that in Latin America(developing only)?
Provide a succinct answer. 1.05. What is the ratio of the Expenditure(as % of GDP) of 1995 in Latin America(all income levels) to that in Least developed countries?
Offer a terse response. 1.48. What is the ratio of the Expenditure(as % of GDP) in 1996 in Latin America(all income levels) to that in Least developed countries?
Provide a short and direct response. 1.51. What is the ratio of the Expenditure(as % of GDP) of 1997 in Latin America(all income levels) to that in Least developed countries?
Your response must be concise. 1.6. What is the ratio of the Expenditure(as % of GDP) in 1998 in Latin America(all income levels) to that in Least developed countries?
Your answer should be compact. 1.57. What is the ratio of the Expenditure(as % of GDP) in 1995 in Latin America(developing only) to that in Least developed countries?
Offer a very short reply. 1.41. What is the ratio of the Expenditure(as % of GDP) in 1996 in Latin America(developing only) to that in Least developed countries?
Your answer should be very brief. 1.46. What is the ratio of the Expenditure(as % of GDP) of 1997 in Latin America(developing only) to that in Least developed countries?
Ensure brevity in your answer.  1.54. What is the ratio of the Expenditure(as % of GDP) in 1998 in Latin America(developing only) to that in Least developed countries?
Offer a terse response. 1.48. What is the difference between the highest and the second highest Expenditure(as % of GDP) of 1995?
Make the answer very short. 0.19. What is the difference between the highest and the second highest Expenditure(as % of GDP) of 1996?
Offer a very short reply. 0.2. What is the difference between the highest and the second highest Expenditure(as % of GDP) in 1997?
Your answer should be compact. 0.2. What is the difference between the highest and the second highest Expenditure(as % of GDP) in 1998?
Provide a short and direct response. 0.18. What is the difference between the highest and the lowest Expenditure(as % of GDP) of 1995?
Your answer should be very brief. 5.21. What is the difference between the highest and the lowest Expenditure(as % of GDP) in 1996?
Offer a very short reply. 5.45. What is the difference between the highest and the lowest Expenditure(as % of GDP) of 1997?
Your response must be concise. 5.7. What is the difference between the highest and the lowest Expenditure(as % of GDP) of 1998?
Provide a succinct answer. 5.81. 